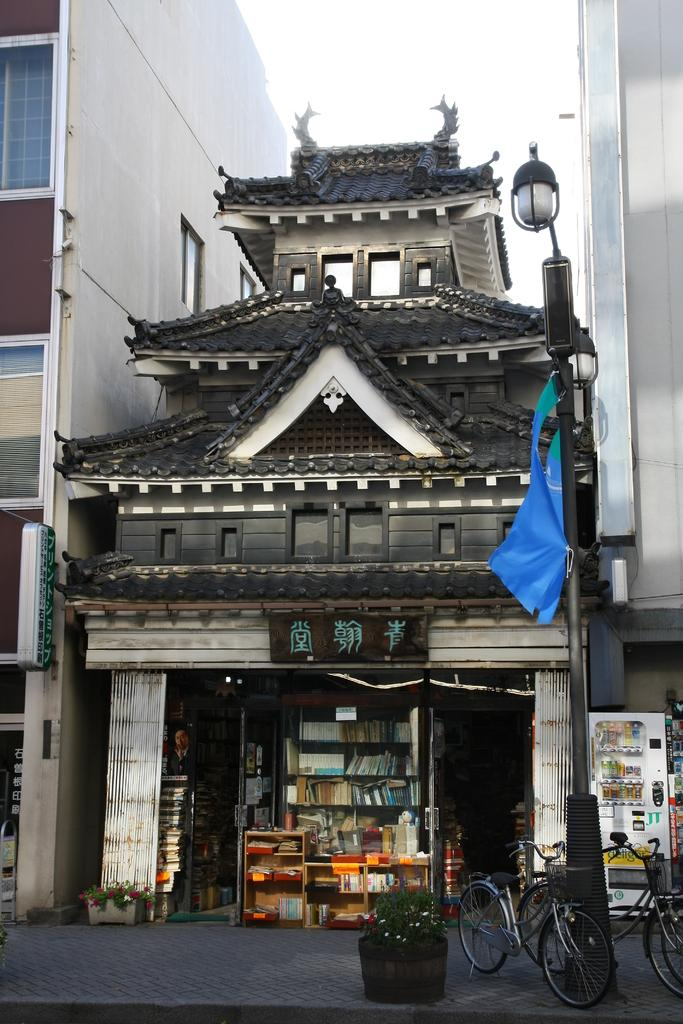What type of structures can be seen in the image? There are buildings in the image. Where is the pole located in the image? The pole is on the right side of the image. What can be found at the bottom of the image? There are bicycles and plants at the bottom of the image. What type of establishment is present in the image? There is a store in the image. What is visible in the background of the image? The sky is visible in the background of the image. What color is the curtain hanging in the store in the image? There is no curtain present in the store in the image. How many bitcoins are visible in the image? There are no bitcoins present in the image. 